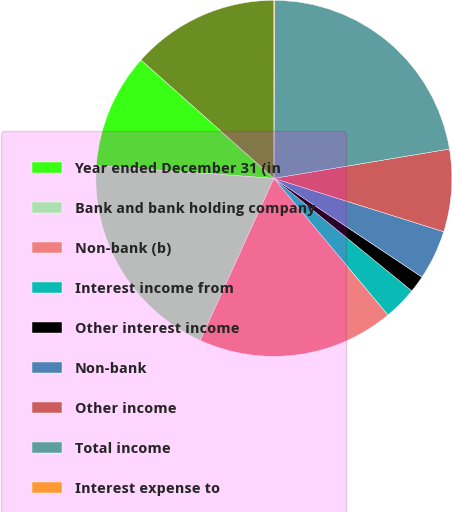<chart> <loc_0><loc_0><loc_500><loc_500><pie_chart><fcel>Year ended December 31 (in<fcel>Bank and bank holding company<fcel>Non-bank (b)<fcel>Interest income from<fcel>Other interest income<fcel>Non-bank<fcel>Other income<fcel>Total income<fcel>Interest expense to<fcel>Other interest expense<nl><fcel>10.45%<fcel>19.35%<fcel>17.86%<fcel>3.03%<fcel>1.54%<fcel>4.51%<fcel>7.48%<fcel>22.31%<fcel>0.06%<fcel>13.41%<nl></chart> 